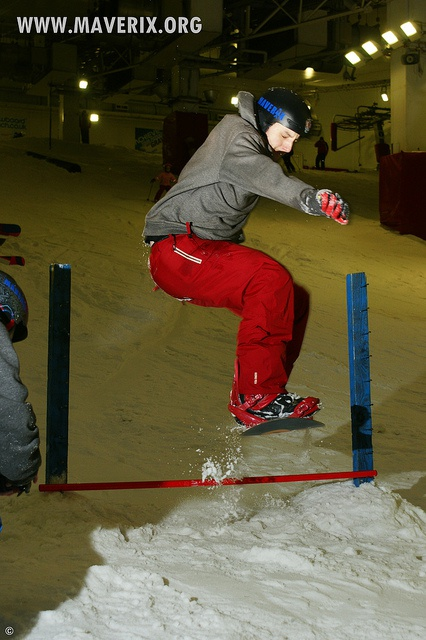Describe the objects in this image and their specific colors. I can see people in black, maroon, and gray tones, people in black, gray, and purple tones, baseball glove in black, salmon, red, and gray tones, snowboard in black, gray, and maroon tones, and people in black and darkgreen tones in this image. 